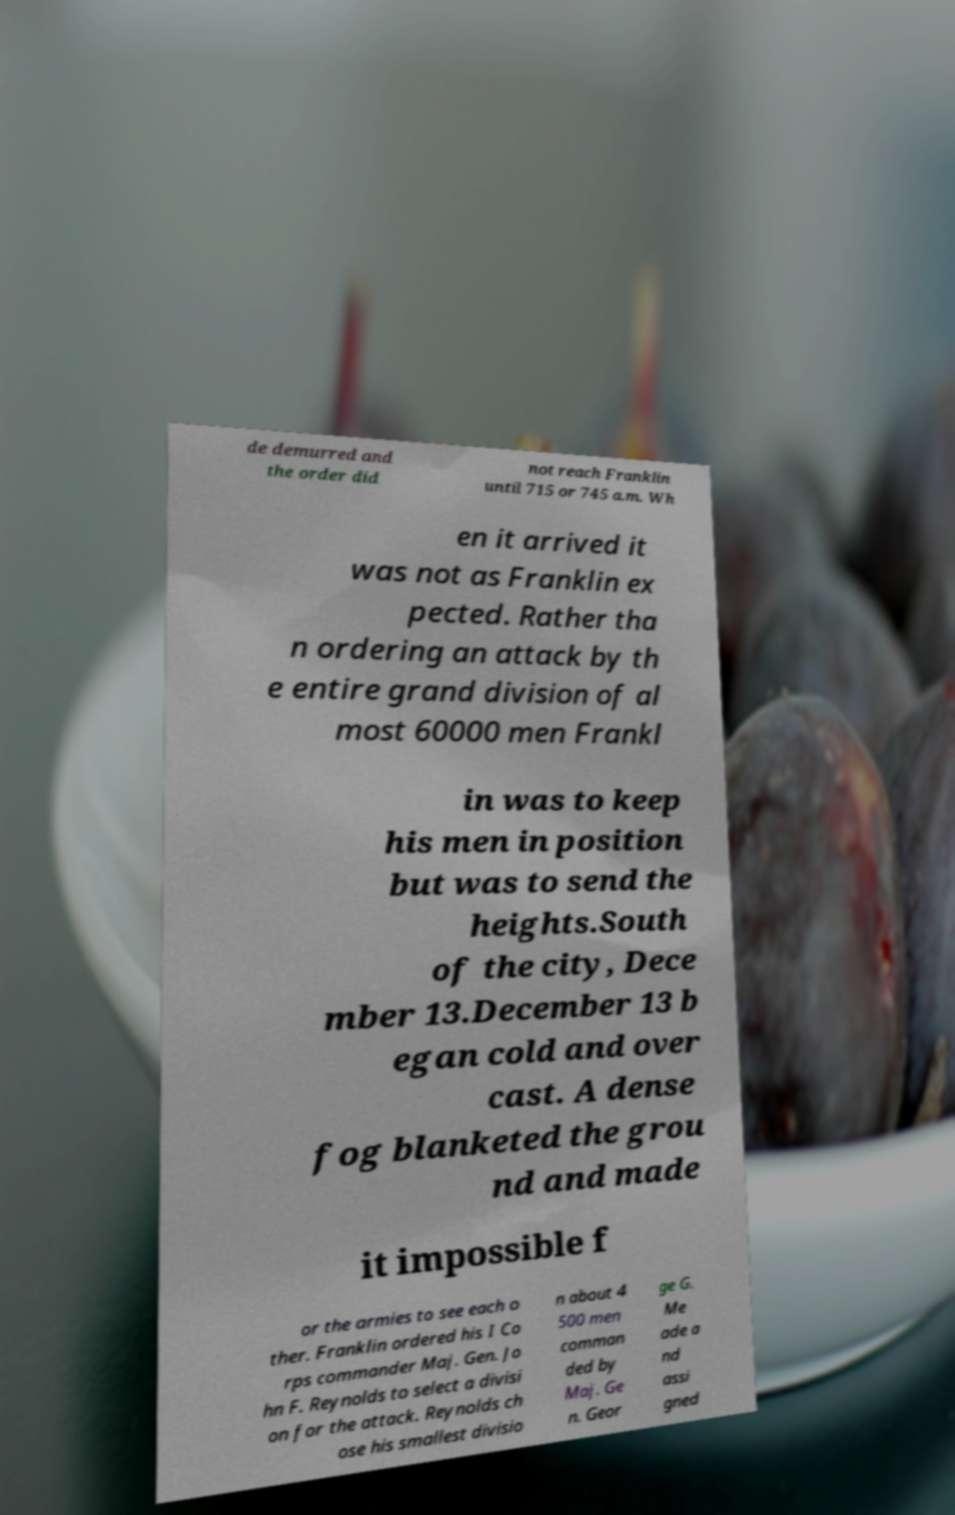Please read and relay the text visible in this image. What does it say? de demurred and the order did not reach Franklin until 715 or 745 a.m. Wh en it arrived it was not as Franklin ex pected. Rather tha n ordering an attack by th e entire grand division of al most 60000 men Frankl in was to keep his men in position but was to send the heights.South of the city, Dece mber 13.December 13 b egan cold and over cast. A dense fog blanketed the grou nd and made it impossible f or the armies to see each o ther. Franklin ordered his I Co rps commander Maj. Gen. Jo hn F. Reynolds to select a divisi on for the attack. Reynolds ch ose his smallest divisio n about 4 500 men comman ded by Maj. Ge n. Geor ge G. Me ade a nd assi gned 